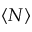Convert formula to latex. <formula><loc_0><loc_0><loc_500><loc_500>\langle N \rangle</formula> 